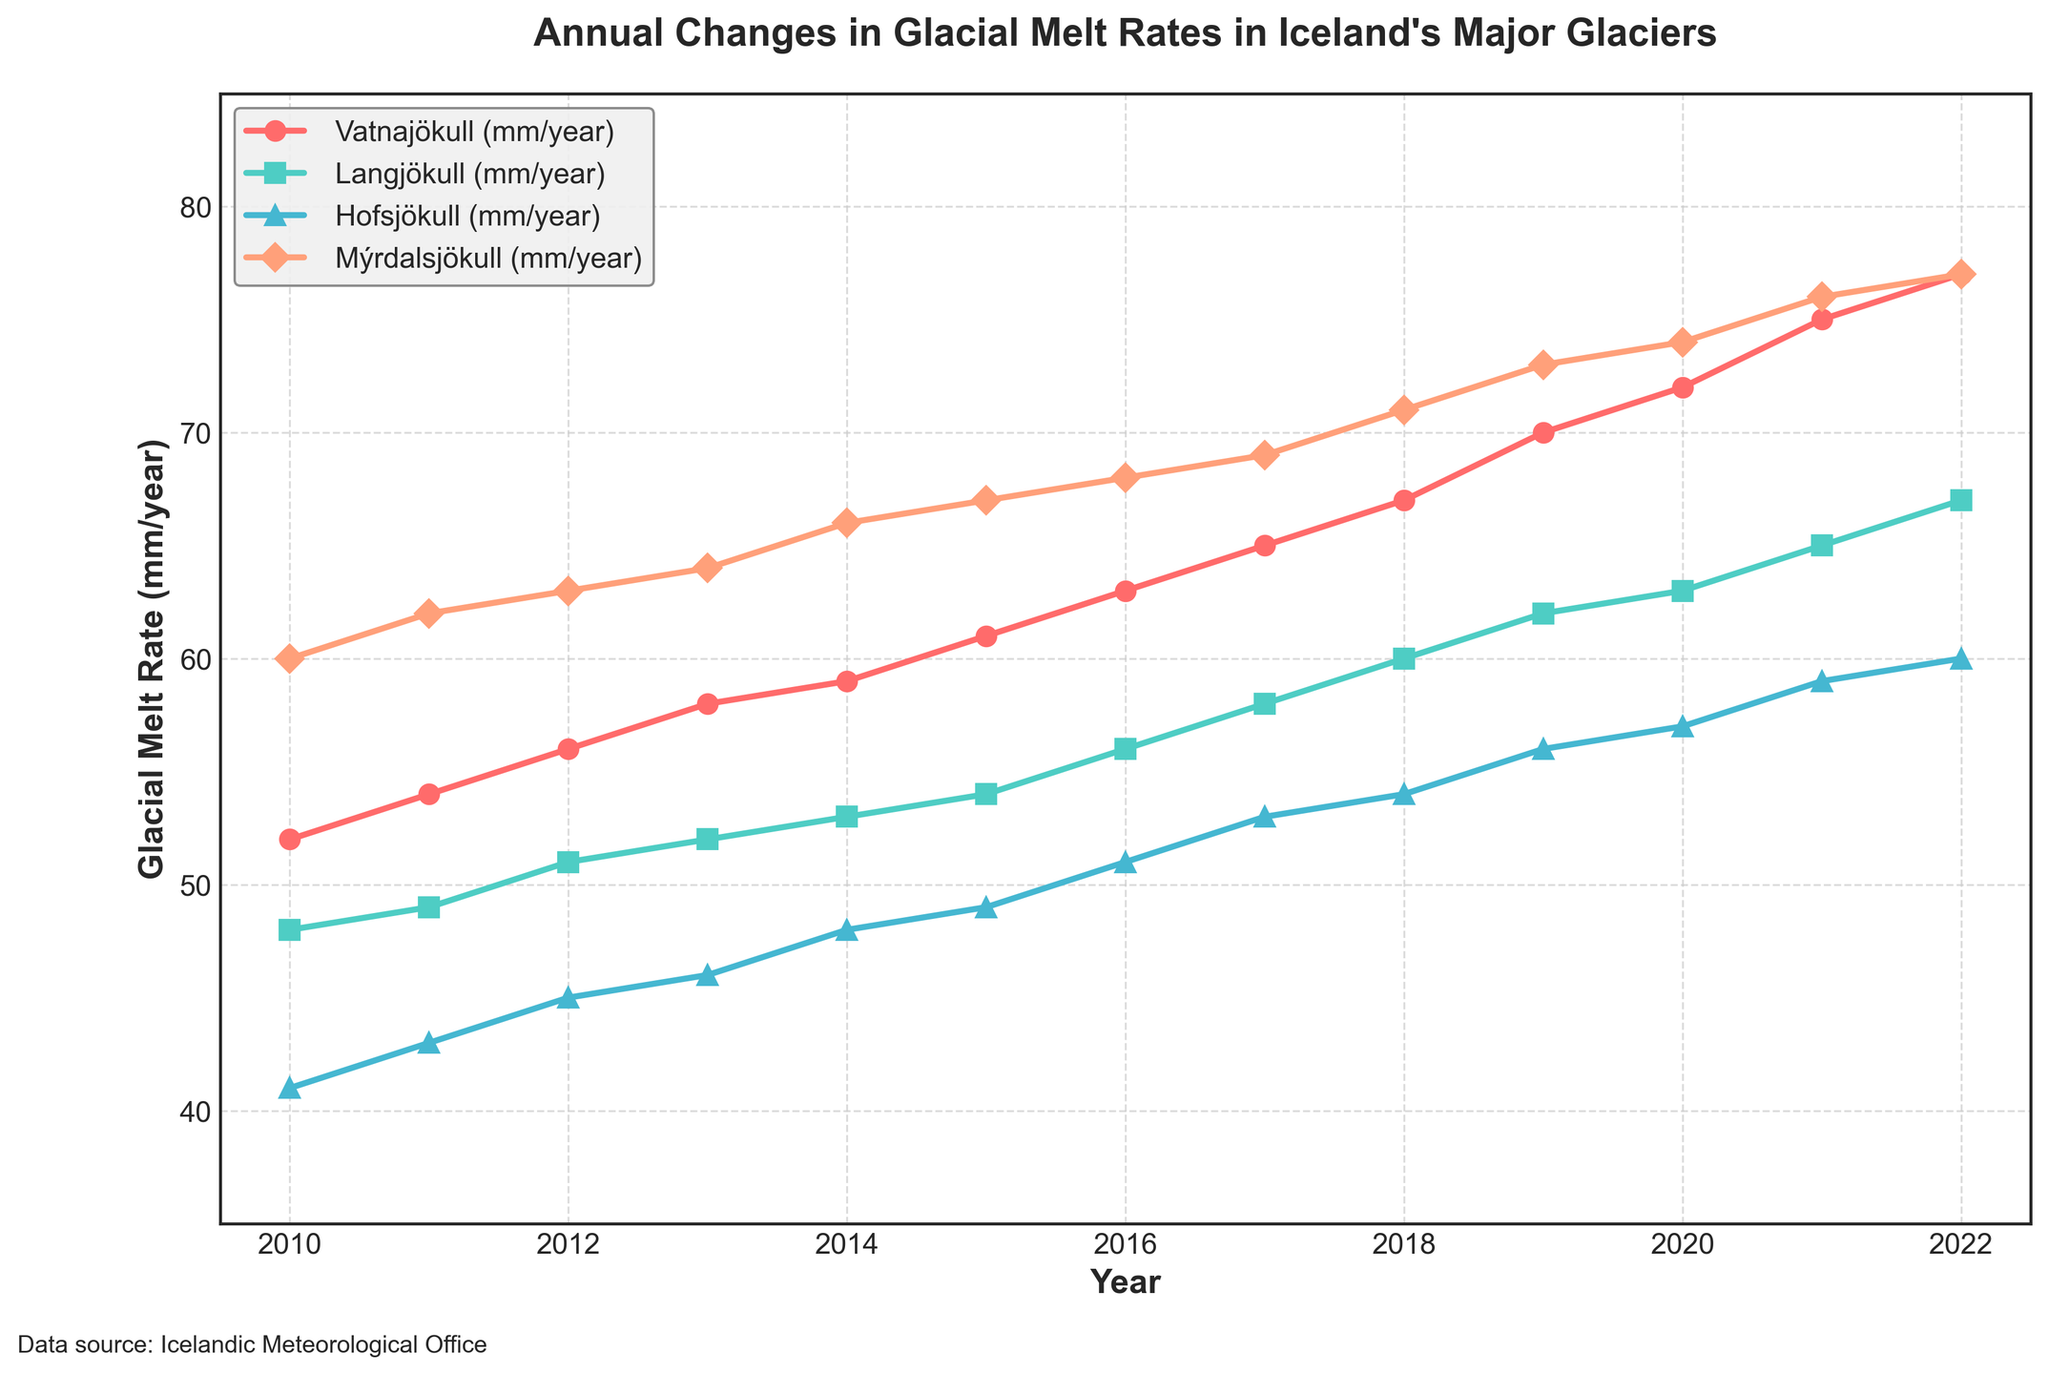What is the title of the figure? The title of the figure is shown at the top of the plot. It provides an overview of the information presented in the figure. The title is "Annual Changes in Glacial Melt Rates in Iceland's Major Glaciers".
Answer: Annual Changes in Glacial Melt Rates in Iceland's Major Glaciers How many glaciers' melt rates are depicted in the figure? Each glacier is represented by a different line in the plot. By counting the lines, you can determine that there are four glaciers depicted.
Answer: Four What measurement unit is used on the Y-axis? The Y-axis label indicates the measurement unit used for the glacial melt rates. It is labeled as "Glacial Melt Rate (mm/year)", meaning millimeters per year.
Answer: mm/year Which glacier had the highest melt rate in 2022? The melt rates for 2022 are represented by the points on the rightmost side of the plot. Among Vatnajökull, Langjökull, Hofsjökull, and Mýrdalsjökull, Mýrdalsjökull had the highest melt rate.
Answer: Mýrdalsjökull Which glacier showed the least change in melt rate over the years? By examining the trend slopes of each glacier's line, the one with the least steep slope represents the glacier with the least change. Hofsjökull shows the least steep slope.
Answer: Hofsjökull Between which years did the largest increase in melt rate occur for Vatnajökull? By inspecting the points for Vatnajökull and their corresponding years, you can determine the largest annual increase by finding the largest gap between two successive points. This occurred between 2021 and 2022.
Answer: 2021 and 2022 What was the average melt rate for Langjökull from 2010 to 2022? To find the average melt rate for Langjökull, sum all the yearly melt rates from 2010 to 2022 and divide by the number of years. The average is (48 + 49 + 51 + 52 + 53 + 54 + 56 + 58 + 60 + 62 + 63 + 65 + 67) / 13 = 57.
Answer: 57 mm/year Compare the melt rates of Vatnajökull and Mýrdalsjökull in 2015. Which was higher and by how much? Look at the melt rates for Vatnajökull and Mýrdalsjökull in 2015. Vatnajökull had a melt rate of 61 mm/year, and Mýrdalsjökull had 67 mm/year. Mýrdalsjökull's rate was higher by 67 - 61 = 6 mm/year.
Answer: Mýrdalsjökull by 6 mm/year From the plot, determine if the melt rates of all glaciers increased from 2010 to 2022. Check the start and end points for each glacier's line from 2010 to 2022. All lines are trending upwards, indicating that the melt rates of all glaciers increased over this period.
Answer: Yes What is the range of melt rates for Hofsjökull from 2010 to 2022? The range is found by subtracting the minimum melt rate from the maximum melt rate for Hofsjökull over the given years. The minimum is 41 mm/year (2010), and the maximum is 60 mm/year (2022), so the range is 60 - 41 = 19 mm/year.
Answer: 19 mm/year 